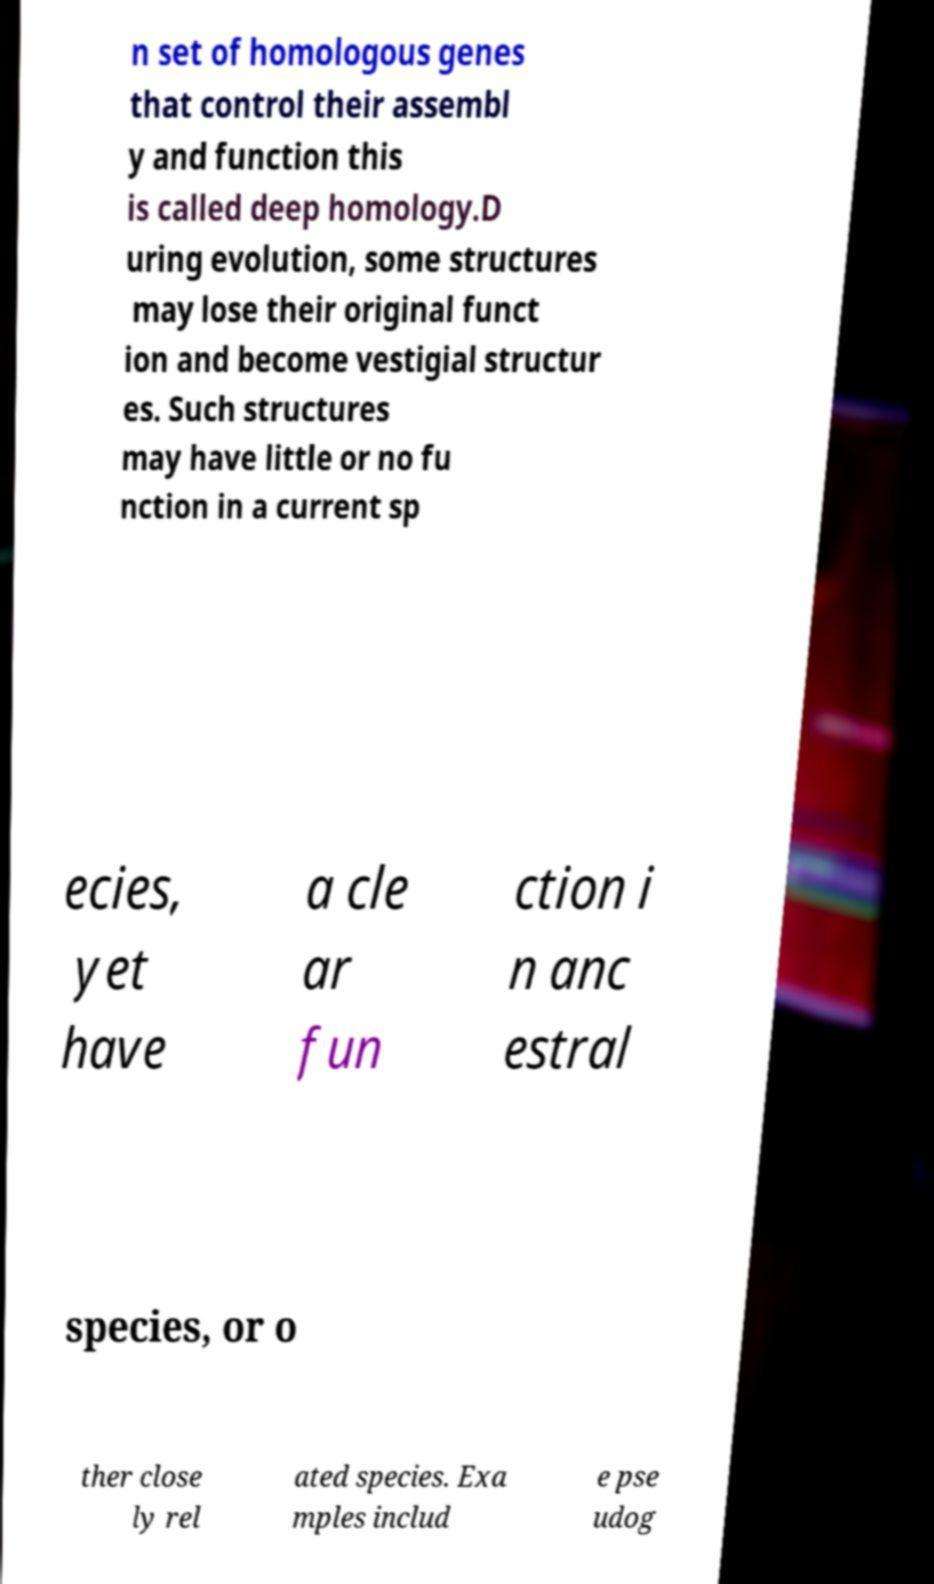What messages or text are displayed in this image? I need them in a readable, typed format. n set of homologous genes that control their assembl y and function this is called deep homology.D uring evolution, some structures may lose their original funct ion and become vestigial structur es. Such structures may have little or no fu nction in a current sp ecies, yet have a cle ar fun ction i n anc estral species, or o ther close ly rel ated species. Exa mples includ e pse udog 